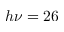<formula> <loc_0><loc_0><loc_500><loc_500>h \nu = 2 6</formula> 